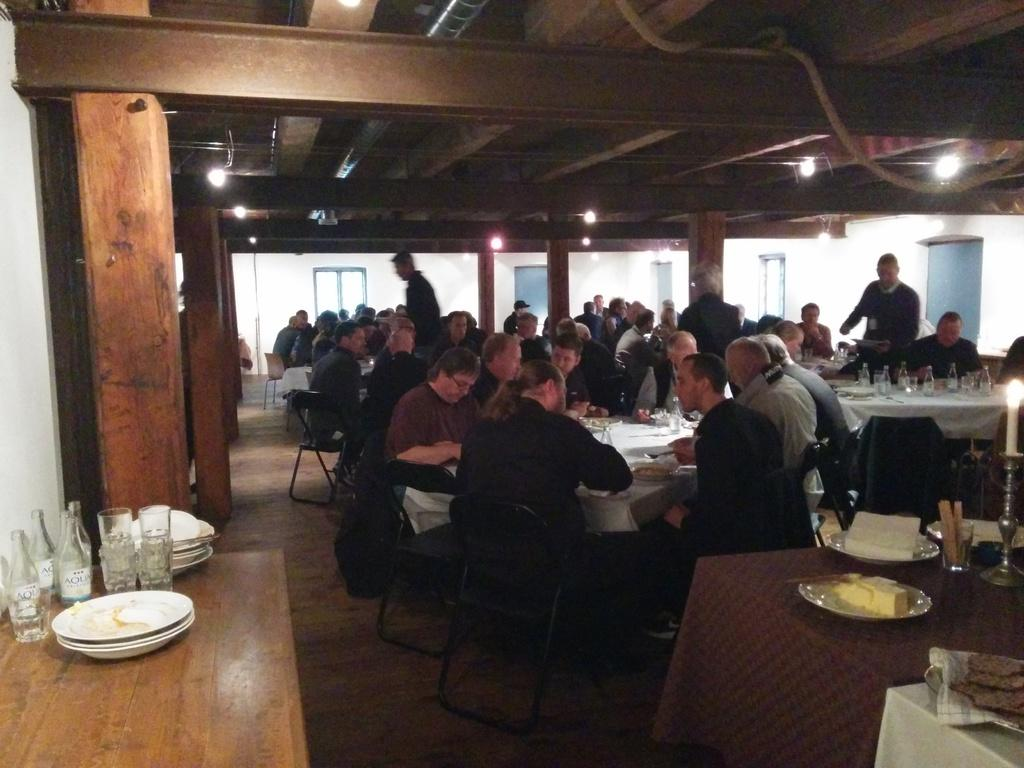How many people are in the image? There is a group of people in the image. What are the people doing in the image? The people are sitting on chairs. Where are the chairs located in relation to the table? The chairs are in front of a table. What can be found on the table in the image? There are plates, glass bottles, and other objects on the table. How many pots are on the table in the image? There are no pots present on the table in the image. 